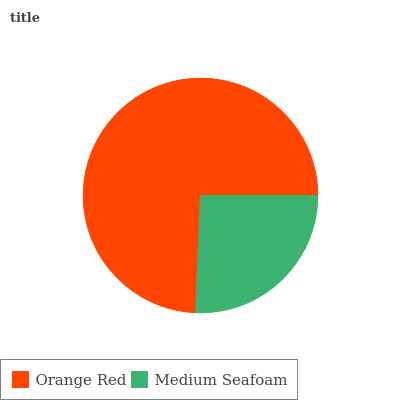Is Medium Seafoam the minimum?
Answer yes or no. Yes. Is Orange Red the maximum?
Answer yes or no. Yes. Is Medium Seafoam the maximum?
Answer yes or no. No. Is Orange Red greater than Medium Seafoam?
Answer yes or no. Yes. Is Medium Seafoam less than Orange Red?
Answer yes or no. Yes. Is Medium Seafoam greater than Orange Red?
Answer yes or no. No. Is Orange Red less than Medium Seafoam?
Answer yes or no. No. Is Orange Red the high median?
Answer yes or no. Yes. Is Medium Seafoam the low median?
Answer yes or no. Yes. Is Medium Seafoam the high median?
Answer yes or no. No. Is Orange Red the low median?
Answer yes or no. No. 